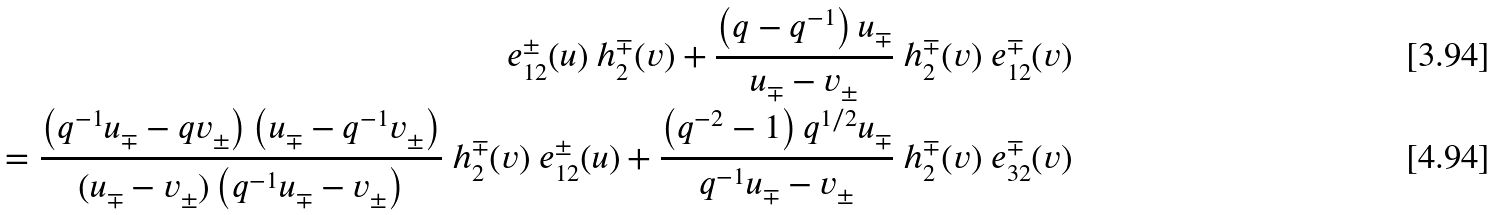<formula> <loc_0><loc_0><loc_500><loc_500>\ e _ { 1 2 } ^ { \pm } ( u ) \ h ^ { \mp } _ { 2 } ( v ) + \frac { \left ( q - q ^ { - 1 } \right ) u _ { \mp } } { u _ { \mp } - v _ { \pm } } \ h ^ { \mp } _ { 2 } ( v ) \ e ^ { \mp } _ { 1 2 } ( v ) \\ = \frac { \left ( q ^ { - 1 } u _ { \mp } - q v _ { \pm } \right ) \left ( u _ { \mp } - q ^ { - 1 } v _ { \pm } \right ) } { ( u _ { \mp } - v _ { \pm } ) \left ( q ^ { - 1 } u _ { \mp } - v _ { \pm } \right ) } \ h ^ { \mp } _ { 2 } ( v ) \ e ^ { \pm } _ { 1 2 } ( u ) + \frac { \left ( q ^ { - 2 } - 1 \right ) q ^ { 1 / 2 } u _ { \mp } } { q ^ { - 1 } u _ { \mp } - v _ { \pm } } \ h ^ { \mp } _ { 2 } ( v ) \ e ^ { \mp } _ { 3 2 } ( v )</formula> 